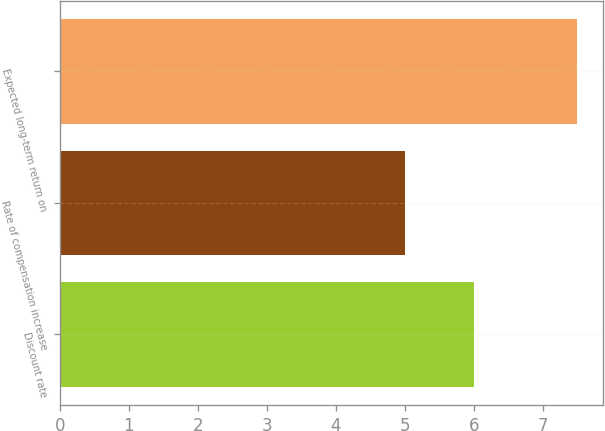Convert chart to OTSL. <chart><loc_0><loc_0><loc_500><loc_500><bar_chart><fcel>Discount rate<fcel>Rate of compensation increase<fcel>Expected long-term return on<nl><fcel>6<fcel>5<fcel>7.5<nl></chart> 